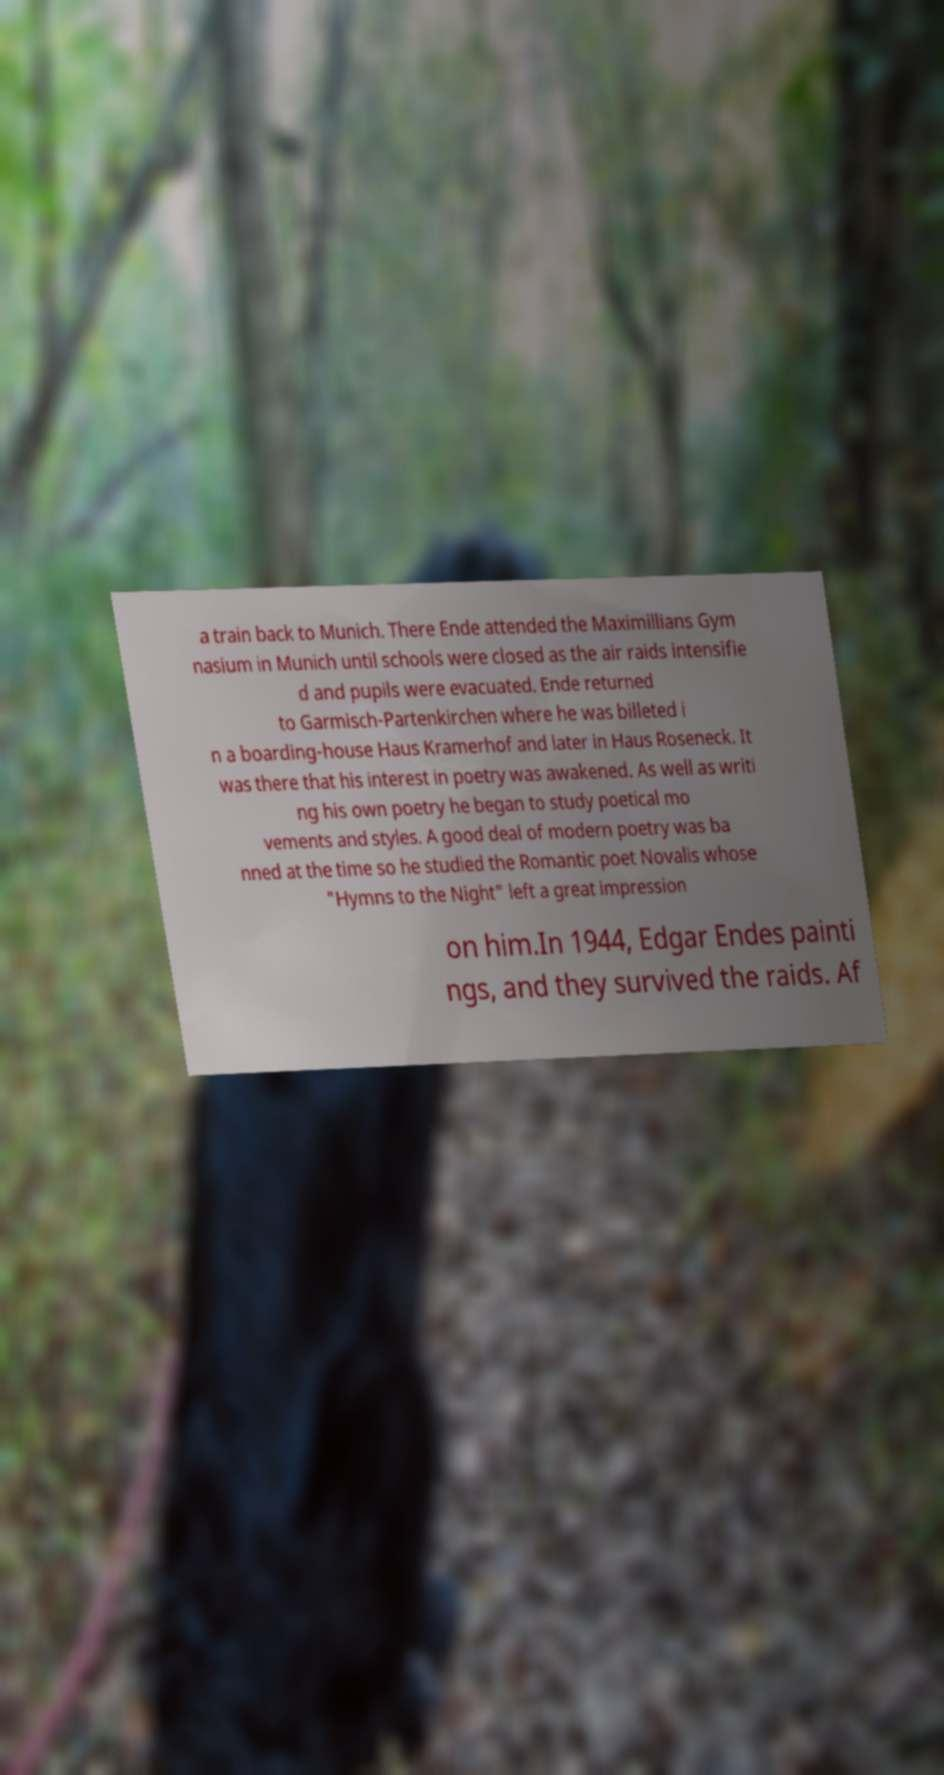Could you extract and type out the text from this image? a train back to Munich. There Ende attended the Maximillians Gym nasium in Munich until schools were closed as the air raids intensifie d and pupils were evacuated. Ende returned to Garmisch-Partenkirchen where he was billeted i n a boarding-house Haus Kramerhof and later in Haus Roseneck. It was there that his interest in poetry was awakened. As well as writi ng his own poetry he began to study poetical mo vements and styles. A good deal of modern poetry was ba nned at the time so he studied the Romantic poet Novalis whose "Hymns to the Night" left a great impression on him.In 1944, Edgar Endes painti ngs, and they survived the raids. Af 